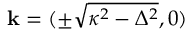Convert formula to latex. <formula><loc_0><loc_0><loc_500><loc_500>k = ( \pm \sqrt { \kappa ^ { 2 } - \Delta ^ { 2 } } , 0 )</formula> 